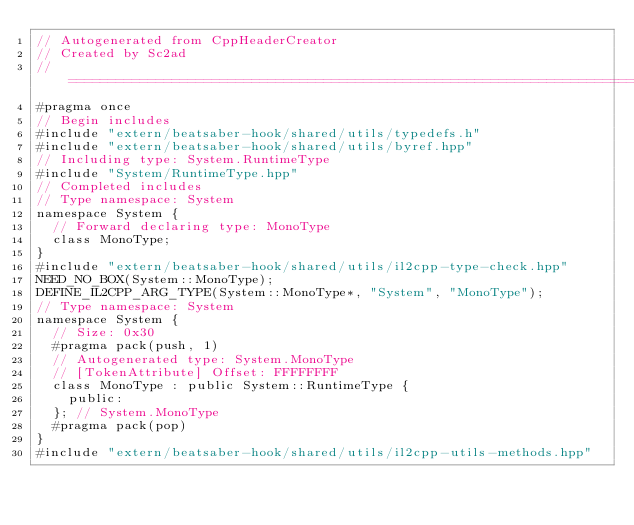Convert code to text. <code><loc_0><loc_0><loc_500><loc_500><_C++_>// Autogenerated from CppHeaderCreator
// Created by Sc2ad
// =========================================================================
#pragma once
// Begin includes
#include "extern/beatsaber-hook/shared/utils/typedefs.h"
#include "extern/beatsaber-hook/shared/utils/byref.hpp"
// Including type: System.RuntimeType
#include "System/RuntimeType.hpp"
// Completed includes
// Type namespace: System
namespace System {
  // Forward declaring type: MonoType
  class MonoType;
}
#include "extern/beatsaber-hook/shared/utils/il2cpp-type-check.hpp"
NEED_NO_BOX(System::MonoType);
DEFINE_IL2CPP_ARG_TYPE(System::MonoType*, "System", "MonoType");
// Type namespace: System
namespace System {
  // Size: 0x30
  #pragma pack(push, 1)
  // Autogenerated type: System.MonoType
  // [TokenAttribute] Offset: FFFFFFFF
  class MonoType : public System::RuntimeType {
    public:
  }; // System.MonoType
  #pragma pack(pop)
}
#include "extern/beatsaber-hook/shared/utils/il2cpp-utils-methods.hpp"
</code> 